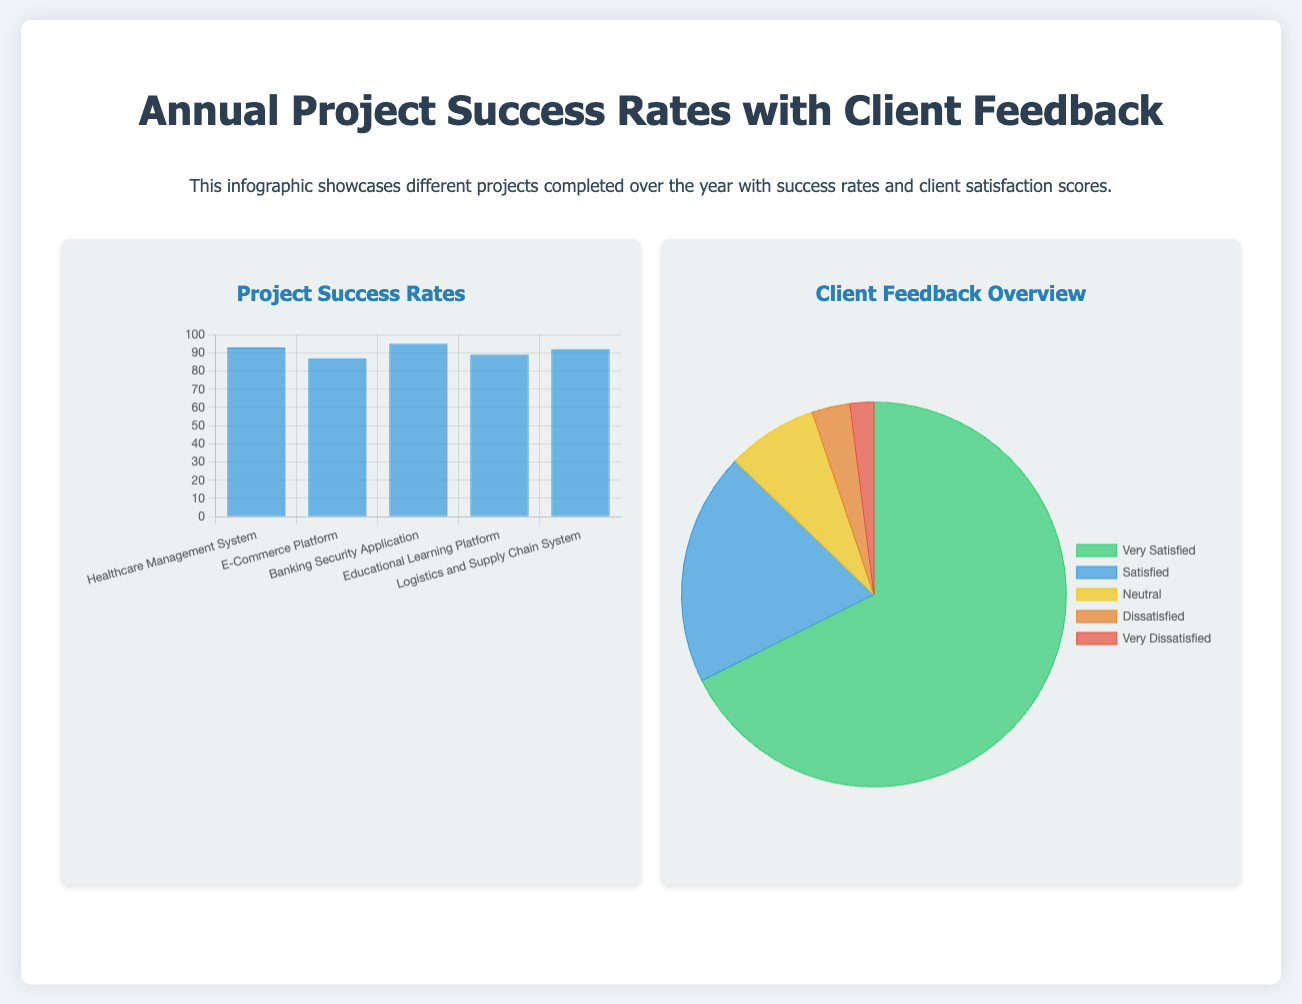what is the success rate of the Healthcare Management System? The success rate is explicitly stated in the bar chart under "Project Success Rates," showing 93 percent.
Answer: 93 which project has the highest success rate? By comparing the success rates in the chart, the project with the highest success rate is the Banking Security Application, at 95 percent.
Answer: Banking Security Application how many clients were very satisfied with the E-Commerce Platform? The pie chart under "Client Feedback Overview" shows that 60 clients were very satisfied, which is derived from the feedback data for that project.
Answer: 60 what percentage of clients were satisfied with the Logistics and Supply Chain System? The satisfied clients make up 18 percent of the feedback, according to the breakdown shown in the pie chart for overall feedback.
Answer: 18 how many projects listed have a success rate above 90 percent? The bar chart shows that there are three projects with a success rate exceeding 90 percent (Healthcare Management System, Banking Security Application, and Logistics and Supply Chain System).
Answer: 3 what is the least number of very dissatisfied clients across all projects? The feedback data indicates that the least number of very dissatisfied clients are 2, as reflected in the feedback for multiple projects.
Answer: 2 what is the total number of clients who gave neutral feedback across all projects? The total neutral feedback total is derived from the sum of neutral client responses from the projects, which equals 43.
Answer: 43 which client feedback category had the highest count overall? The pie chart shows that the "Very Satisfied" category had the highest count, totaling 338 clients, based on the feedback data.
Answer: Very Satisfied 